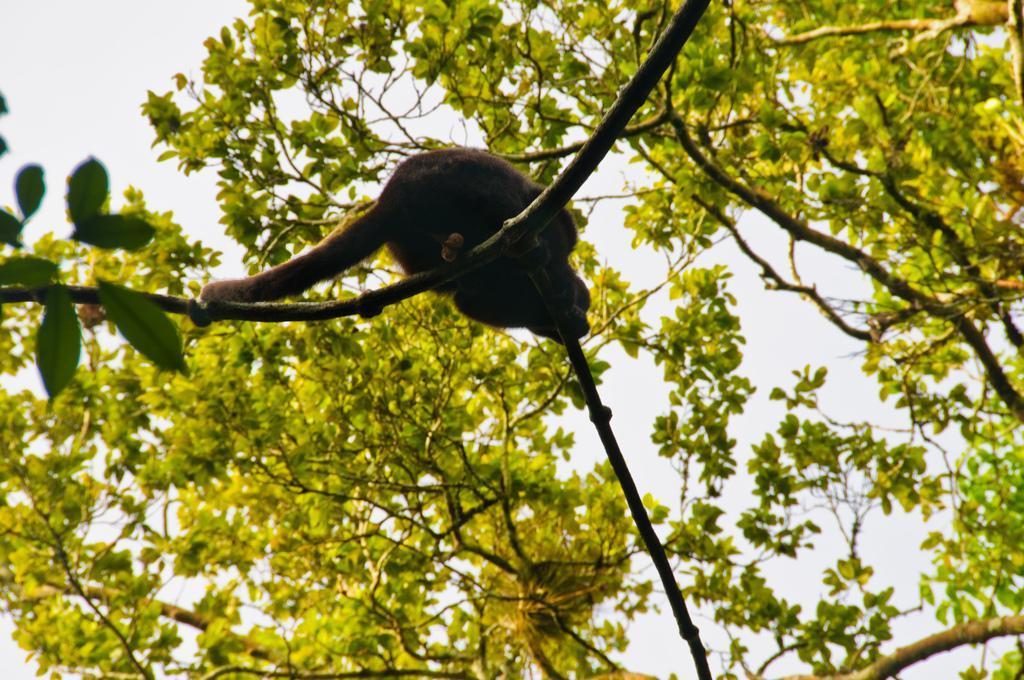Describe this image in one or two sentences. In this image we can see an animal on the tree. In the background there are trees and sky. 